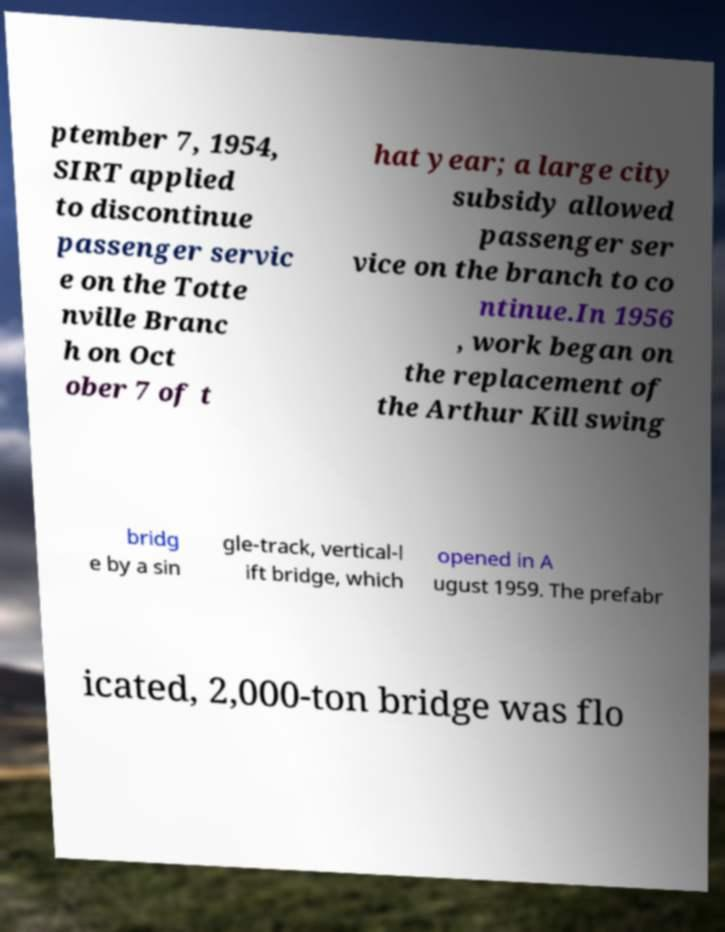Please read and relay the text visible in this image. What does it say? ptember 7, 1954, SIRT applied to discontinue passenger servic e on the Totte nville Branc h on Oct ober 7 of t hat year; a large city subsidy allowed passenger ser vice on the branch to co ntinue.In 1956 , work began on the replacement of the Arthur Kill swing bridg e by a sin gle-track, vertical-l ift bridge, which opened in A ugust 1959. The prefabr icated, 2,000-ton bridge was flo 